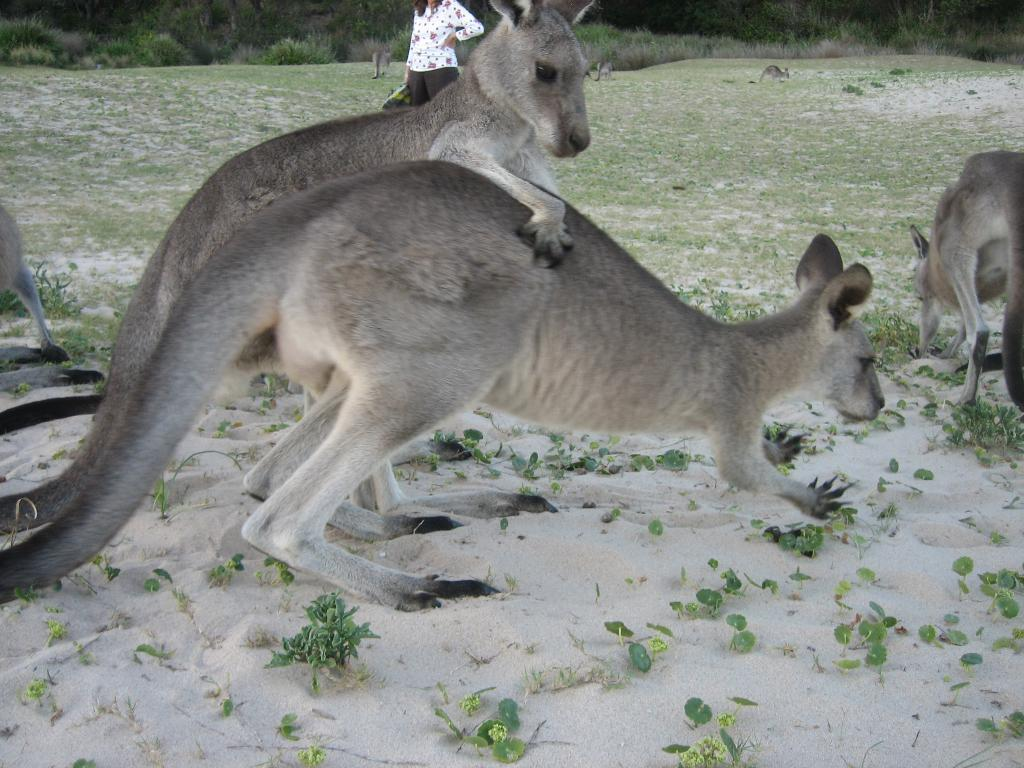What animals are present in the image? There are many kangaroos in the image. What colors are the kangaroos? The kangaroos are black and gray in color. Can you describe the person in the image? There is a person standing in the image, and they are wearing clothes. What type of terrain is visible in the image? There is grass, plants, and sand in the image. What is the reaction of the girl to the snake in the image? There is no girl or snake present in the image; it features many kangaroos, a person, and various types of terrain. 